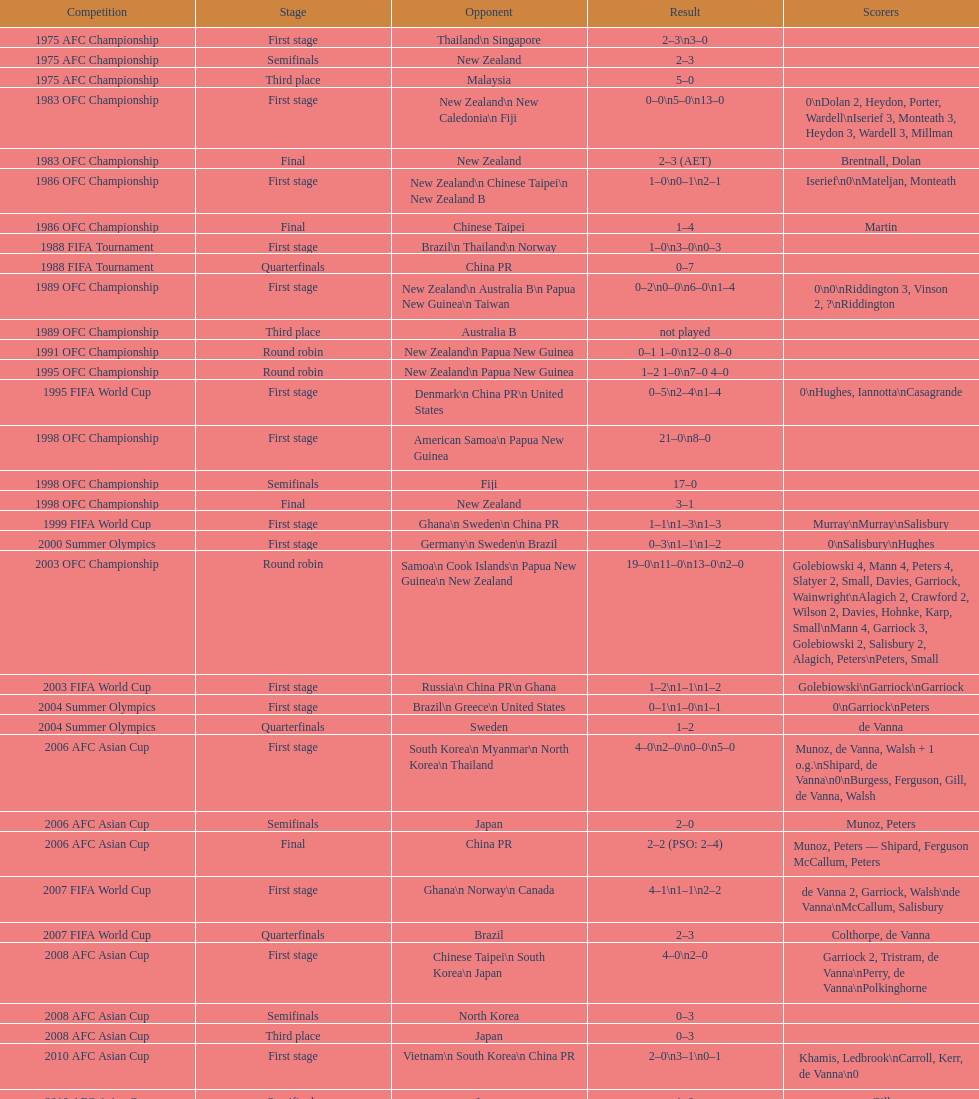How many points were scored in the final round of the 2012 summer olympics afc qualification? 12. 